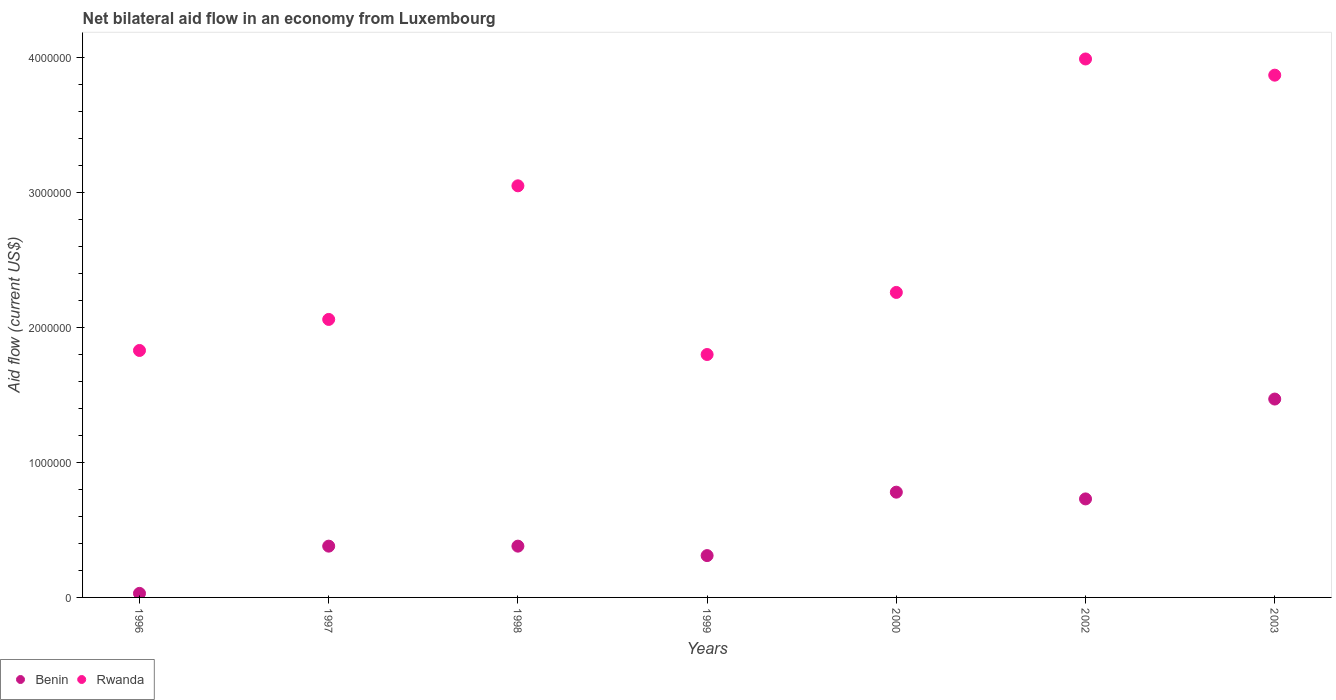What is the net bilateral aid flow in Rwanda in 1998?
Ensure brevity in your answer.  3.05e+06. Across all years, what is the maximum net bilateral aid flow in Benin?
Give a very brief answer. 1.47e+06. Across all years, what is the minimum net bilateral aid flow in Rwanda?
Ensure brevity in your answer.  1.80e+06. What is the total net bilateral aid flow in Rwanda in the graph?
Your answer should be very brief. 1.89e+07. What is the difference between the net bilateral aid flow in Rwanda in 1997 and that in 1998?
Offer a very short reply. -9.90e+05. What is the difference between the net bilateral aid flow in Benin in 1998 and the net bilateral aid flow in Rwanda in 1997?
Your answer should be compact. -1.68e+06. What is the average net bilateral aid flow in Benin per year?
Offer a terse response. 5.83e+05. In the year 1997, what is the difference between the net bilateral aid flow in Rwanda and net bilateral aid flow in Benin?
Your answer should be compact. 1.68e+06. In how many years, is the net bilateral aid flow in Rwanda greater than 2400000 US$?
Your answer should be very brief. 3. What is the ratio of the net bilateral aid flow in Benin in 1997 to that in 1999?
Provide a succinct answer. 1.23. Is the difference between the net bilateral aid flow in Rwanda in 1998 and 1999 greater than the difference between the net bilateral aid flow in Benin in 1998 and 1999?
Your answer should be compact. Yes. What is the difference between the highest and the second highest net bilateral aid flow in Benin?
Your response must be concise. 6.90e+05. What is the difference between the highest and the lowest net bilateral aid flow in Benin?
Your answer should be compact. 1.44e+06. In how many years, is the net bilateral aid flow in Benin greater than the average net bilateral aid flow in Benin taken over all years?
Make the answer very short. 3. Is the sum of the net bilateral aid flow in Benin in 1996 and 1999 greater than the maximum net bilateral aid flow in Rwanda across all years?
Provide a short and direct response. No. Does the net bilateral aid flow in Benin monotonically increase over the years?
Your answer should be compact. No. How many years are there in the graph?
Keep it short and to the point. 7. What is the difference between two consecutive major ticks on the Y-axis?
Your answer should be compact. 1.00e+06. Does the graph contain any zero values?
Ensure brevity in your answer.  No. Does the graph contain grids?
Ensure brevity in your answer.  No. Where does the legend appear in the graph?
Your response must be concise. Bottom left. How are the legend labels stacked?
Give a very brief answer. Horizontal. What is the title of the graph?
Provide a short and direct response. Net bilateral aid flow in an economy from Luxembourg. What is the Aid flow (current US$) in Benin in 1996?
Your response must be concise. 3.00e+04. What is the Aid flow (current US$) of Rwanda in 1996?
Give a very brief answer. 1.83e+06. What is the Aid flow (current US$) of Benin in 1997?
Provide a short and direct response. 3.80e+05. What is the Aid flow (current US$) of Rwanda in 1997?
Your answer should be very brief. 2.06e+06. What is the Aid flow (current US$) of Benin in 1998?
Your answer should be compact. 3.80e+05. What is the Aid flow (current US$) of Rwanda in 1998?
Keep it short and to the point. 3.05e+06. What is the Aid flow (current US$) of Benin in 1999?
Your answer should be compact. 3.10e+05. What is the Aid flow (current US$) of Rwanda in 1999?
Your response must be concise. 1.80e+06. What is the Aid flow (current US$) in Benin in 2000?
Your answer should be very brief. 7.80e+05. What is the Aid flow (current US$) of Rwanda in 2000?
Your answer should be very brief. 2.26e+06. What is the Aid flow (current US$) in Benin in 2002?
Offer a very short reply. 7.30e+05. What is the Aid flow (current US$) of Rwanda in 2002?
Provide a succinct answer. 3.99e+06. What is the Aid flow (current US$) of Benin in 2003?
Provide a succinct answer. 1.47e+06. What is the Aid flow (current US$) of Rwanda in 2003?
Provide a succinct answer. 3.87e+06. Across all years, what is the maximum Aid flow (current US$) in Benin?
Your answer should be compact. 1.47e+06. Across all years, what is the maximum Aid flow (current US$) of Rwanda?
Provide a short and direct response. 3.99e+06. Across all years, what is the minimum Aid flow (current US$) of Rwanda?
Your response must be concise. 1.80e+06. What is the total Aid flow (current US$) in Benin in the graph?
Your answer should be very brief. 4.08e+06. What is the total Aid flow (current US$) of Rwanda in the graph?
Your answer should be very brief. 1.89e+07. What is the difference between the Aid flow (current US$) in Benin in 1996 and that in 1997?
Your response must be concise. -3.50e+05. What is the difference between the Aid flow (current US$) in Benin in 1996 and that in 1998?
Provide a succinct answer. -3.50e+05. What is the difference between the Aid flow (current US$) in Rwanda in 1996 and that in 1998?
Give a very brief answer. -1.22e+06. What is the difference between the Aid flow (current US$) of Benin in 1996 and that in 1999?
Make the answer very short. -2.80e+05. What is the difference between the Aid flow (current US$) in Rwanda in 1996 and that in 1999?
Give a very brief answer. 3.00e+04. What is the difference between the Aid flow (current US$) in Benin in 1996 and that in 2000?
Provide a short and direct response. -7.50e+05. What is the difference between the Aid flow (current US$) in Rwanda in 1996 and that in 2000?
Give a very brief answer. -4.30e+05. What is the difference between the Aid flow (current US$) in Benin in 1996 and that in 2002?
Keep it short and to the point. -7.00e+05. What is the difference between the Aid flow (current US$) of Rwanda in 1996 and that in 2002?
Offer a very short reply. -2.16e+06. What is the difference between the Aid flow (current US$) of Benin in 1996 and that in 2003?
Provide a short and direct response. -1.44e+06. What is the difference between the Aid flow (current US$) in Rwanda in 1996 and that in 2003?
Offer a very short reply. -2.04e+06. What is the difference between the Aid flow (current US$) of Benin in 1997 and that in 1998?
Keep it short and to the point. 0. What is the difference between the Aid flow (current US$) in Rwanda in 1997 and that in 1998?
Give a very brief answer. -9.90e+05. What is the difference between the Aid flow (current US$) of Rwanda in 1997 and that in 1999?
Keep it short and to the point. 2.60e+05. What is the difference between the Aid flow (current US$) in Benin in 1997 and that in 2000?
Your response must be concise. -4.00e+05. What is the difference between the Aid flow (current US$) in Rwanda in 1997 and that in 2000?
Your answer should be very brief. -2.00e+05. What is the difference between the Aid flow (current US$) in Benin in 1997 and that in 2002?
Your response must be concise. -3.50e+05. What is the difference between the Aid flow (current US$) in Rwanda in 1997 and that in 2002?
Keep it short and to the point. -1.93e+06. What is the difference between the Aid flow (current US$) of Benin in 1997 and that in 2003?
Make the answer very short. -1.09e+06. What is the difference between the Aid flow (current US$) of Rwanda in 1997 and that in 2003?
Make the answer very short. -1.81e+06. What is the difference between the Aid flow (current US$) in Benin in 1998 and that in 1999?
Your answer should be compact. 7.00e+04. What is the difference between the Aid flow (current US$) of Rwanda in 1998 and that in 1999?
Your answer should be compact. 1.25e+06. What is the difference between the Aid flow (current US$) of Benin in 1998 and that in 2000?
Offer a very short reply. -4.00e+05. What is the difference between the Aid flow (current US$) in Rwanda in 1998 and that in 2000?
Offer a very short reply. 7.90e+05. What is the difference between the Aid flow (current US$) in Benin in 1998 and that in 2002?
Make the answer very short. -3.50e+05. What is the difference between the Aid flow (current US$) of Rwanda in 1998 and that in 2002?
Make the answer very short. -9.40e+05. What is the difference between the Aid flow (current US$) of Benin in 1998 and that in 2003?
Offer a terse response. -1.09e+06. What is the difference between the Aid flow (current US$) of Rwanda in 1998 and that in 2003?
Make the answer very short. -8.20e+05. What is the difference between the Aid flow (current US$) of Benin in 1999 and that in 2000?
Give a very brief answer. -4.70e+05. What is the difference between the Aid flow (current US$) of Rwanda in 1999 and that in 2000?
Provide a succinct answer. -4.60e+05. What is the difference between the Aid flow (current US$) in Benin in 1999 and that in 2002?
Your answer should be very brief. -4.20e+05. What is the difference between the Aid flow (current US$) in Rwanda in 1999 and that in 2002?
Ensure brevity in your answer.  -2.19e+06. What is the difference between the Aid flow (current US$) of Benin in 1999 and that in 2003?
Make the answer very short. -1.16e+06. What is the difference between the Aid flow (current US$) in Rwanda in 1999 and that in 2003?
Ensure brevity in your answer.  -2.07e+06. What is the difference between the Aid flow (current US$) of Benin in 2000 and that in 2002?
Ensure brevity in your answer.  5.00e+04. What is the difference between the Aid flow (current US$) of Rwanda in 2000 and that in 2002?
Give a very brief answer. -1.73e+06. What is the difference between the Aid flow (current US$) of Benin in 2000 and that in 2003?
Your answer should be compact. -6.90e+05. What is the difference between the Aid flow (current US$) in Rwanda in 2000 and that in 2003?
Provide a succinct answer. -1.61e+06. What is the difference between the Aid flow (current US$) of Benin in 2002 and that in 2003?
Your answer should be compact. -7.40e+05. What is the difference between the Aid flow (current US$) of Rwanda in 2002 and that in 2003?
Offer a very short reply. 1.20e+05. What is the difference between the Aid flow (current US$) of Benin in 1996 and the Aid flow (current US$) of Rwanda in 1997?
Your answer should be very brief. -2.03e+06. What is the difference between the Aid flow (current US$) in Benin in 1996 and the Aid flow (current US$) in Rwanda in 1998?
Provide a short and direct response. -3.02e+06. What is the difference between the Aid flow (current US$) of Benin in 1996 and the Aid flow (current US$) of Rwanda in 1999?
Provide a short and direct response. -1.77e+06. What is the difference between the Aid flow (current US$) in Benin in 1996 and the Aid flow (current US$) in Rwanda in 2000?
Give a very brief answer. -2.23e+06. What is the difference between the Aid flow (current US$) in Benin in 1996 and the Aid flow (current US$) in Rwanda in 2002?
Keep it short and to the point. -3.96e+06. What is the difference between the Aid flow (current US$) of Benin in 1996 and the Aid flow (current US$) of Rwanda in 2003?
Your answer should be very brief. -3.84e+06. What is the difference between the Aid flow (current US$) in Benin in 1997 and the Aid flow (current US$) in Rwanda in 1998?
Provide a succinct answer. -2.67e+06. What is the difference between the Aid flow (current US$) of Benin in 1997 and the Aid flow (current US$) of Rwanda in 1999?
Your response must be concise. -1.42e+06. What is the difference between the Aid flow (current US$) in Benin in 1997 and the Aid flow (current US$) in Rwanda in 2000?
Your answer should be very brief. -1.88e+06. What is the difference between the Aid flow (current US$) of Benin in 1997 and the Aid flow (current US$) of Rwanda in 2002?
Your answer should be very brief. -3.61e+06. What is the difference between the Aid flow (current US$) in Benin in 1997 and the Aid flow (current US$) in Rwanda in 2003?
Make the answer very short. -3.49e+06. What is the difference between the Aid flow (current US$) of Benin in 1998 and the Aid flow (current US$) of Rwanda in 1999?
Provide a succinct answer. -1.42e+06. What is the difference between the Aid flow (current US$) in Benin in 1998 and the Aid flow (current US$) in Rwanda in 2000?
Offer a terse response. -1.88e+06. What is the difference between the Aid flow (current US$) in Benin in 1998 and the Aid flow (current US$) in Rwanda in 2002?
Give a very brief answer. -3.61e+06. What is the difference between the Aid flow (current US$) of Benin in 1998 and the Aid flow (current US$) of Rwanda in 2003?
Your answer should be very brief. -3.49e+06. What is the difference between the Aid flow (current US$) of Benin in 1999 and the Aid flow (current US$) of Rwanda in 2000?
Keep it short and to the point. -1.95e+06. What is the difference between the Aid flow (current US$) of Benin in 1999 and the Aid flow (current US$) of Rwanda in 2002?
Provide a succinct answer. -3.68e+06. What is the difference between the Aid flow (current US$) of Benin in 1999 and the Aid flow (current US$) of Rwanda in 2003?
Your response must be concise. -3.56e+06. What is the difference between the Aid flow (current US$) in Benin in 2000 and the Aid flow (current US$) in Rwanda in 2002?
Your answer should be very brief. -3.21e+06. What is the difference between the Aid flow (current US$) in Benin in 2000 and the Aid flow (current US$) in Rwanda in 2003?
Ensure brevity in your answer.  -3.09e+06. What is the difference between the Aid flow (current US$) in Benin in 2002 and the Aid flow (current US$) in Rwanda in 2003?
Offer a terse response. -3.14e+06. What is the average Aid flow (current US$) of Benin per year?
Ensure brevity in your answer.  5.83e+05. What is the average Aid flow (current US$) of Rwanda per year?
Your answer should be very brief. 2.69e+06. In the year 1996, what is the difference between the Aid flow (current US$) in Benin and Aid flow (current US$) in Rwanda?
Offer a terse response. -1.80e+06. In the year 1997, what is the difference between the Aid flow (current US$) of Benin and Aid flow (current US$) of Rwanda?
Offer a very short reply. -1.68e+06. In the year 1998, what is the difference between the Aid flow (current US$) of Benin and Aid flow (current US$) of Rwanda?
Give a very brief answer. -2.67e+06. In the year 1999, what is the difference between the Aid flow (current US$) of Benin and Aid flow (current US$) of Rwanda?
Give a very brief answer. -1.49e+06. In the year 2000, what is the difference between the Aid flow (current US$) of Benin and Aid flow (current US$) of Rwanda?
Provide a succinct answer. -1.48e+06. In the year 2002, what is the difference between the Aid flow (current US$) of Benin and Aid flow (current US$) of Rwanda?
Keep it short and to the point. -3.26e+06. In the year 2003, what is the difference between the Aid flow (current US$) of Benin and Aid flow (current US$) of Rwanda?
Your response must be concise. -2.40e+06. What is the ratio of the Aid flow (current US$) in Benin in 1996 to that in 1997?
Give a very brief answer. 0.08. What is the ratio of the Aid flow (current US$) of Rwanda in 1996 to that in 1997?
Offer a terse response. 0.89. What is the ratio of the Aid flow (current US$) in Benin in 1996 to that in 1998?
Keep it short and to the point. 0.08. What is the ratio of the Aid flow (current US$) in Benin in 1996 to that in 1999?
Your answer should be compact. 0.1. What is the ratio of the Aid flow (current US$) of Rwanda in 1996 to that in 1999?
Your answer should be very brief. 1.02. What is the ratio of the Aid flow (current US$) in Benin in 1996 to that in 2000?
Your answer should be very brief. 0.04. What is the ratio of the Aid flow (current US$) in Rwanda in 1996 to that in 2000?
Offer a terse response. 0.81. What is the ratio of the Aid flow (current US$) of Benin in 1996 to that in 2002?
Your answer should be very brief. 0.04. What is the ratio of the Aid flow (current US$) of Rwanda in 1996 to that in 2002?
Your answer should be compact. 0.46. What is the ratio of the Aid flow (current US$) of Benin in 1996 to that in 2003?
Give a very brief answer. 0.02. What is the ratio of the Aid flow (current US$) in Rwanda in 1996 to that in 2003?
Ensure brevity in your answer.  0.47. What is the ratio of the Aid flow (current US$) in Rwanda in 1997 to that in 1998?
Offer a terse response. 0.68. What is the ratio of the Aid flow (current US$) in Benin in 1997 to that in 1999?
Give a very brief answer. 1.23. What is the ratio of the Aid flow (current US$) of Rwanda in 1997 to that in 1999?
Your response must be concise. 1.14. What is the ratio of the Aid flow (current US$) in Benin in 1997 to that in 2000?
Offer a very short reply. 0.49. What is the ratio of the Aid flow (current US$) in Rwanda in 1997 to that in 2000?
Your answer should be compact. 0.91. What is the ratio of the Aid flow (current US$) of Benin in 1997 to that in 2002?
Your answer should be compact. 0.52. What is the ratio of the Aid flow (current US$) in Rwanda in 1997 to that in 2002?
Make the answer very short. 0.52. What is the ratio of the Aid flow (current US$) of Benin in 1997 to that in 2003?
Your answer should be compact. 0.26. What is the ratio of the Aid flow (current US$) of Rwanda in 1997 to that in 2003?
Your answer should be very brief. 0.53. What is the ratio of the Aid flow (current US$) in Benin in 1998 to that in 1999?
Your response must be concise. 1.23. What is the ratio of the Aid flow (current US$) in Rwanda in 1998 to that in 1999?
Provide a succinct answer. 1.69. What is the ratio of the Aid flow (current US$) in Benin in 1998 to that in 2000?
Your answer should be very brief. 0.49. What is the ratio of the Aid flow (current US$) of Rwanda in 1998 to that in 2000?
Ensure brevity in your answer.  1.35. What is the ratio of the Aid flow (current US$) in Benin in 1998 to that in 2002?
Offer a terse response. 0.52. What is the ratio of the Aid flow (current US$) in Rwanda in 1998 to that in 2002?
Offer a terse response. 0.76. What is the ratio of the Aid flow (current US$) of Benin in 1998 to that in 2003?
Ensure brevity in your answer.  0.26. What is the ratio of the Aid flow (current US$) of Rwanda in 1998 to that in 2003?
Your response must be concise. 0.79. What is the ratio of the Aid flow (current US$) of Benin in 1999 to that in 2000?
Your answer should be compact. 0.4. What is the ratio of the Aid flow (current US$) of Rwanda in 1999 to that in 2000?
Give a very brief answer. 0.8. What is the ratio of the Aid flow (current US$) of Benin in 1999 to that in 2002?
Keep it short and to the point. 0.42. What is the ratio of the Aid flow (current US$) in Rwanda in 1999 to that in 2002?
Offer a very short reply. 0.45. What is the ratio of the Aid flow (current US$) of Benin in 1999 to that in 2003?
Offer a very short reply. 0.21. What is the ratio of the Aid flow (current US$) of Rwanda in 1999 to that in 2003?
Offer a very short reply. 0.47. What is the ratio of the Aid flow (current US$) of Benin in 2000 to that in 2002?
Ensure brevity in your answer.  1.07. What is the ratio of the Aid flow (current US$) in Rwanda in 2000 to that in 2002?
Ensure brevity in your answer.  0.57. What is the ratio of the Aid flow (current US$) in Benin in 2000 to that in 2003?
Offer a very short reply. 0.53. What is the ratio of the Aid flow (current US$) in Rwanda in 2000 to that in 2003?
Provide a short and direct response. 0.58. What is the ratio of the Aid flow (current US$) in Benin in 2002 to that in 2003?
Offer a terse response. 0.5. What is the ratio of the Aid flow (current US$) of Rwanda in 2002 to that in 2003?
Offer a terse response. 1.03. What is the difference between the highest and the second highest Aid flow (current US$) in Benin?
Your answer should be very brief. 6.90e+05. What is the difference between the highest and the second highest Aid flow (current US$) in Rwanda?
Offer a terse response. 1.20e+05. What is the difference between the highest and the lowest Aid flow (current US$) in Benin?
Keep it short and to the point. 1.44e+06. What is the difference between the highest and the lowest Aid flow (current US$) in Rwanda?
Your answer should be very brief. 2.19e+06. 